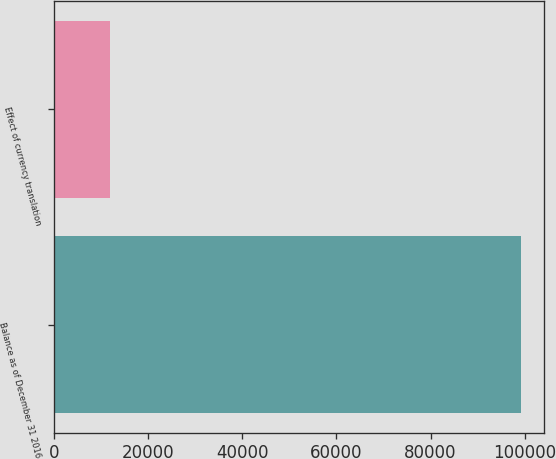Convert chart. <chart><loc_0><loc_0><loc_500><loc_500><bar_chart><fcel>Balance as of December 31 2016<fcel>Effect of currency translation<nl><fcel>99245<fcel>11910<nl></chart> 